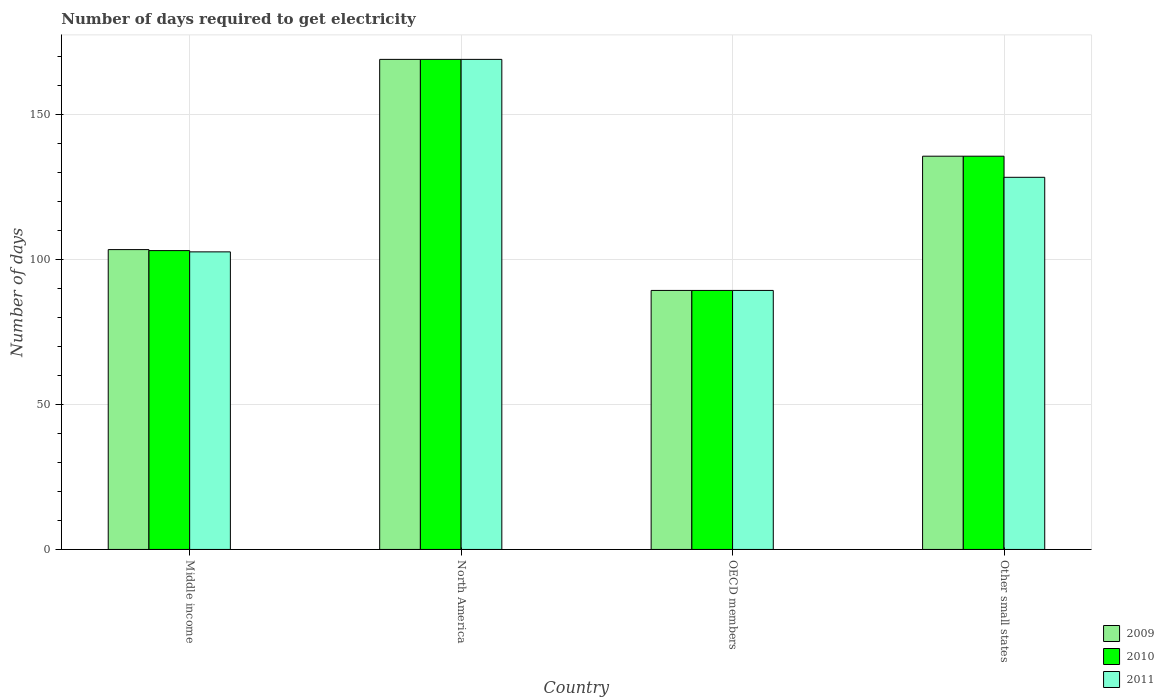Are the number of bars on each tick of the X-axis equal?
Your answer should be very brief. Yes. How many bars are there on the 1st tick from the right?
Provide a succinct answer. 3. What is the label of the 4th group of bars from the left?
Offer a very short reply. Other small states. What is the number of days required to get electricity in in 2009 in Middle income?
Ensure brevity in your answer.  103.4. Across all countries, what is the maximum number of days required to get electricity in in 2010?
Keep it short and to the point. 169. Across all countries, what is the minimum number of days required to get electricity in in 2011?
Ensure brevity in your answer.  89.32. In which country was the number of days required to get electricity in in 2010 maximum?
Keep it short and to the point. North America. In which country was the number of days required to get electricity in in 2011 minimum?
Ensure brevity in your answer.  OECD members. What is the total number of days required to get electricity in in 2010 in the graph?
Your answer should be compact. 496.99. What is the difference between the number of days required to get electricity in in 2011 in North America and that in OECD members?
Ensure brevity in your answer.  79.68. What is the difference between the number of days required to get electricity in in 2011 in Other small states and the number of days required to get electricity in in 2010 in Middle income?
Offer a very short reply. 25.28. What is the average number of days required to get electricity in in 2010 per country?
Provide a short and direct response. 124.25. What is the difference between the number of days required to get electricity in of/in 2010 and number of days required to get electricity in of/in 2011 in Other small states?
Provide a short and direct response. 7.28. In how many countries, is the number of days required to get electricity in in 2011 greater than 130 days?
Your response must be concise. 1. What is the ratio of the number of days required to get electricity in in 2009 in North America to that in OECD members?
Provide a succinct answer. 1.89. Is the number of days required to get electricity in in 2009 in North America less than that in Other small states?
Provide a short and direct response. No. What is the difference between the highest and the second highest number of days required to get electricity in in 2009?
Your answer should be very brief. 65.6. What is the difference between the highest and the lowest number of days required to get electricity in in 2009?
Ensure brevity in your answer.  79.68. Is the sum of the number of days required to get electricity in in 2010 in Middle income and North America greater than the maximum number of days required to get electricity in in 2009 across all countries?
Keep it short and to the point. Yes. How many bars are there?
Give a very brief answer. 12. How many countries are there in the graph?
Your answer should be compact. 4. Does the graph contain grids?
Make the answer very short. Yes. How many legend labels are there?
Your response must be concise. 3. What is the title of the graph?
Your answer should be very brief. Number of days required to get electricity. What is the label or title of the X-axis?
Ensure brevity in your answer.  Country. What is the label or title of the Y-axis?
Provide a short and direct response. Number of days. What is the Number of days of 2009 in Middle income?
Keep it short and to the point. 103.4. What is the Number of days in 2010 in Middle income?
Provide a succinct answer. 103.06. What is the Number of days in 2011 in Middle income?
Make the answer very short. 102.62. What is the Number of days of 2009 in North America?
Your response must be concise. 169. What is the Number of days of 2010 in North America?
Provide a succinct answer. 169. What is the Number of days of 2011 in North America?
Provide a succinct answer. 169. What is the Number of days in 2009 in OECD members?
Give a very brief answer. 89.32. What is the Number of days of 2010 in OECD members?
Your response must be concise. 89.32. What is the Number of days in 2011 in OECD members?
Provide a succinct answer. 89.32. What is the Number of days in 2009 in Other small states?
Your answer should be very brief. 135.61. What is the Number of days of 2010 in Other small states?
Your answer should be compact. 135.61. What is the Number of days of 2011 in Other small states?
Offer a terse response. 128.33. Across all countries, what is the maximum Number of days in 2009?
Provide a succinct answer. 169. Across all countries, what is the maximum Number of days in 2010?
Your answer should be compact. 169. Across all countries, what is the maximum Number of days in 2011?
Offer a terse response. 169. Across all countries, what is the minimum Number of days of 2009?
Make the answer very short. 89.32. Across all countries, what is the minimum Number of days of 2010?
Your answer should be compact. 89.32. Across all countries, what is the minimum Number of days of 2011?
Your answer should be very brief. 89.32. What is the total Number of days of 2009 in the graph?
Ensure brevity in your answer.  497.33. What is the total Number of days of 2010 in the graph?
Your response must be concise. 496.99. What is the total Number of days of 2011 in the graph?
Offer a terse response. 489.28. What is the difference between the Number of days of 2009 in Middle income and that in North America?
Your response must be concise. -65.6. What is the difference between the Number of days in 2010 in Middle income and that in North America?
Keep it short and to the point. -65.94. What is the difference between the Number of days of 2011 in Middle income and that in North America?
Keep it short and to the point. -66.38. What is the difference between the Number of days of 2009 in Middle income and that in OECD members?
Make the answer very short. 14.08. What is the difference between the Number of days of 2010 in Middle income and that in OECD members?
Ensure brevity in your answer.  13.73. What is the difference between the Number of days in 2011 in Middle income and that in OECD members?
Your answer should be compact. 13.3. What is the difference between the Number of days of 2009 in Middle income and that in Other small states?
Offer a very short reply. -32.21. What is the difference between the Number of days in 2010 in Middle income and that in Other small states?
Offer a very short reply. -32.56. What is the difference between the Number of days of 2011 in Middle income and that in Other small states?
Offer a very short reply. -25.71. What is the difference between the Number of days in 2009 in North America and that in OECD members?
Offer a very short reply. 79.68. What is the difference between the Number of days of 2010 in North America and that in OECD members?
Your answer should be compact. 79.68. What is the difference between the Number of days of 2011 in North America and that in OECD members?
Keep it short and to the point. 79.68. What is the difference between the Number of days in 2009 in North America and that in Other small states?
Your answer should be compact. 33.39. What is the difference between the Number of days of 2010 in North America and that in Other small states?
Give a very brief answer. 33.39. What is the difference between the Number of days of 2011 in North America and that in Other small states?
Your answer should be compact. 40.67. What is the difference between the Number of days of 2009 in OECD members and that in Other small states?
Your response must be concise. -46.29. What is the difference between the Number of days of 2010 in OECD members and that in Other small states?
Your answer should be compact. -46.29. What is the difference between the Number of days in 2011 in OECD members and that in Other small states?
Provide a succinct answer. -39.01. What is the difference between the Number of days of 2009 in Middle income and the Number of days of 2010 in North America?
Ensure brevity in your answer.  -65.6. What is the difference between the Number of days of 2009 in Middle income and the Number of days of 2011 in North America?
Your answer should be compact. -65.6. What is the difference between the Number of days in 2010 in Middle income and the Number of days in 2011 in North America?
Give a very brief answer. -65.94. What is the difference between the Number of days in 2009 in Middle income and the Number of days in 2010 in OECD members?
Make the answer very short. 14.08. What is the difference between the Number of days in 2009 in Middle income and the Number of days in 2011 in OECD members?
Provide a succinct answer. 14.08. What is the difference between the Number of days in 2010 in Middle income and the Number of days in 2011 in OECD members?
Make the answer very short. 13.73. What is the difference between the Number of days in 2009 in Middle income and the Number of days in 2010 in Other small states?
Provide a succinct answer. -32.21. What is the difference between the Number of days in 2009 in Middle income and the Number of days in 2011 in Other small states?
Provide a short and direct response. -24.93. What is the difference between the Number of days in 2010 in Middle income and the Number of days in 2011 in Other small states?
Offer a terse response. -25.28. What is the difference between the Number of days of 2009 in North America and the Number of days of 2010 in OECD members?
Offer a very short reply. 79.68. What is the difference between the Number of days of 2009 in North America and the Number of days of 2011 in OECD members?
Keep it short and to the point. 79.68. What is the difference between the Number of days of 2010 in North America and the Number of days of 2011 in OECD members?
Your answer should be very brief. 79.68. What is the difference between the Number of days of 2009 in North America and the Number of days of 2010 in Other small states?
Make the answer very short. 33.39. What is the difference between the Number of days of 2009 in North America and the Number of days of 2011 in Other small states?
Provide a succinct answer. 40.67. What is the difference between the Number of days in 2010 in North America and the Number of days in 2011 in Other small states?
Offer a very short reply. 40.67. What is the difference between the Number of days in 2009 in OECD members and the Number of days in 2010 in Other small states?
Offer a terse response. -46.29. What is the difference between the Number of days in 2009 in OECD members and the Number of days in 2011 in Other small states?
Keep it short and to the point. -39.01. What is the difference between the Number of days in 2010 in OECD members and the Number of days in 2011 in Other small states?
Offer a terse response. -39.01. What is the average Number of days in 2009 per country?
Provide a short and direct response. 124.33. What is the average Number of days in 2010 per country?
Provide a short and direct response. 124.25. What is the average Number of days in 2011 per country?
Make the answer very short. 122.32. What is the difference between the Number of days in 2009 and Number of days in 2010 in Middle income?
Offer a terse response. 0.34. What is the difference between the Number of days in 2009 and Number of days in 2011 in Middle income?
Keep it short and to the point. 0.78. What is the difference between the Number of days in 2010 and Number of days in 2011 in Middle income?
Your answer should be compact. 0.43. What is the difference between the Number of days of 2010 and Number of days of 2011 in North America?
Your response must be concise. 0. What is the difference between the Number of days in 2009 and Number of days in 2011 in OECD members?
Offer a very short reply. 0. What is the difference between the Number of days of 2009 and Number of days of 2011 in Other small states?
Offer a very short reply. 7.28. What is the difference between the Number of days of 2010 and Number of days of 2011 in Other small states?
Ensure brevity in your answer.  7.28. What is the ratio of the Number of days in 2009 in Middle income to that in North America?
Provide a short and direct response. 0.61. What is the ratio of the Number of days of 2010 in Middle income to that in North America?
Ensure brevity in your answer.  0.61. What is the ratio of the Number of days in 2011 in Middle income to that in North America?
Make the answer very short. 0.61. What is the ratio of the Number of days of 2009 in Middle income to that in OECD members?
Provide a succinct answer. 1.16. What is the ratio of the Number of days of 2010 in Middle income to that in OECD members?
Ensure brevity in your answer.  1.15. What is the ratio of the Number of days in 2011 in Middle income to that in OECD members?
Make the answer very short. 1.15. What is the ratio of the Number of days of 2009 in Middle income to that in Other small states?
Provide a succinct answer. 0.76. What is the ratio of the Number of days in 2010 in Middle income to that in Other small states?
Provide a short and direct response. 0.76. What is the ratio of the Number of days of 2011 in Middle income to that in Other small states?
Provide a short and direct response. 0.8. What is the ratio of the Number of days of 2009 in North America to that in OECD members?
Offer a very short reply. 1.89. What is the ratio of the Number of days in 2010 in North America to that in OECD members?
Your answer should be compact. 1.89. What is the ratio of the Number of days in 2011 in North America to that in OECD members?
Offer a terse response. 1.89. What is the ratio of the Number of days in 2009 in North America to that in Other small states?
Your answer should be very brief. 1.25. What is the ratio of the Number of days of 2010 in North America to that in Other small states?
Offer a terse response. 1.25. What is the ratio of the Number of days of 2011 in North America to that in Other small states?
Your answer should be very brief. 1.32. What is the ratio of the Number of days in 2009 in OECD members to that in Other small states?
Provide a short and direct response. 0.66. What is the ratio of the Number of days of 2010 in OECD members to that in Other small states?
Your response must be concise. 0.66. What is the ratio of the Number of days in 2011 in OECD members to that in Other small states?
Offer a very short reply. 0.7. What is the difference between the highest and the second highest Number of days in 2009?
Give a very brief answer. 33.39. What is the difference between the highest and the second highest Number of days of 2010?
Keep it short and to the point. 33.39. What is the difference between the highest and the second highest Number of days of 2011?
Provide a short and direct response. 40.67. What is the difference between the highest and the lowest Number of days in 2009?
Your answer should be compact. 79.68. What is the difference between the highest and the lowest Number of days in 2010?
Your answer should be very brief. 79.68. What is the difference between the highest and the lowest Number of days of 2011?
Your answer should be very brief. 79.68. 